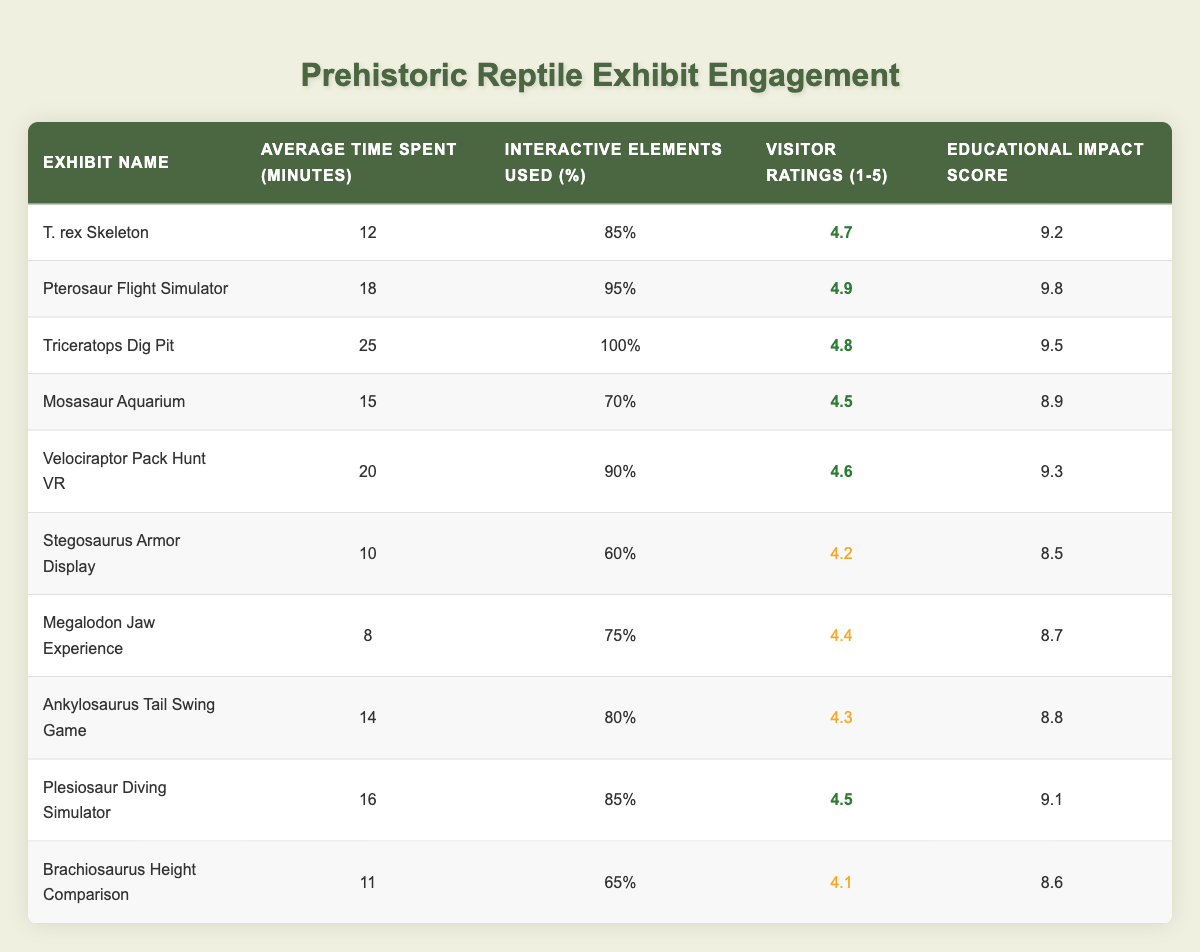What is the average time spent in the Triceratops Dig Pit exhibit? The average time spent in the Triceratops Dig Pit exhibit is listed directly in the table under "Average Time Spent (minutes)" corresponding to the exhibit name. It shows 25 minutes.
Answer: 25 minutes Which exhibit has the highest visitor rating? The visitor ratings are displayed under the "Visitor Ratings (1-5)" column. Comparing the ratings, the Pterosaur Flight Simulator has the highest rating of 4.9.
Answer: 4.9 Is the Educational Impact Score for the Velociraptor Pack Hunt VR higher than that for the Mosasaur Aquarium? The Educational Impact Score for the Velociraptor Pack Hunt VR is 9.3, while for the Mosasaur Aquarium, it is 8.9. Since 9.3 is greater than 8.9, the statement is true.
Answer: Yes What is the average educational impact score of all exhibits? To find the average Educational Impact Score, sum all the scores: (9.2 + 9.8 + 9.5 + 8.9 + 9.3 + 8.5 + 8.7 + 8.8 + 9.1 + 8.6) = 88.4. There are 10 exhibits, so the average is 88.4 divided by 10, equaling 8.84.
Answer: 8.84 How many minutes do visitors spend, on average, in exhibits with more than 80% interactive elements used? The exhibits with over 80% interactive elements are: Pterosaur Flight Simulator (18), Triceratops Dig Pit (25), Velociraptor Pack Hunt VR (20), Plesiosaur Diving Simulator (16), Ankylosaurus Tail Swing Game (14). Summing these gives 18 + 25 + 20 + 16 + 14 = 93 minutes. Then, divide by 5 exhibits to get the average: 93/5 = 18.6 minutes.
Answer: 18.6 minutes Does the Stegosaurus Armor Display have a higher average time spent than the Brachiosaurus Height Comparison? The average time spent in the Stegosaurus Armor Display is 10 minutes, while for the Brachiosaurus Height Comparison, it is 11 minutes. Since 10 is less than 11, the statement is false.
Answer: No What percentage of interactive elements are used in the Megalodon Jaw Experience exhibit? The interactive elements used percentage for the Megalodon Jaw Experience is directly stated in the table under the "Interactive Elements Used (%)" column, showing it is 75%.
Answer: 75% Which exhibit has the lowest visitor rating, and what is that rating? The lowest visitor rating can be found by checking the "Visitor Ratings (1-5)" values for each exhibit. The Stegosaurus Armor Display has the lowest rating of 4.2.
Answer: 4.2 